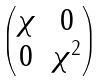Convert formula to latex. <formula><loc_0><loc_0><loc_500><loc_500>\begin{pmatrix} \chi & 0 \\ 0 & \chi ^ { 2 } \end{pmatrix}</formula> 